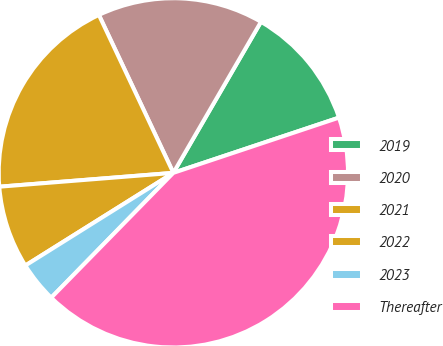Convert chart. <chart><loc_0><loc_0><loc_500><loc_500><pie_chart><fcel>2019<fcel>2020<fcel>2021<fcel>2022<fcel>2023<fcel>Thereafter<nl><fcel>11.51%<fcel>15.38%<fcel>19.25%<fcel>7.64%<fcel>3.77%<fcel>42.45%<nl></chart> 